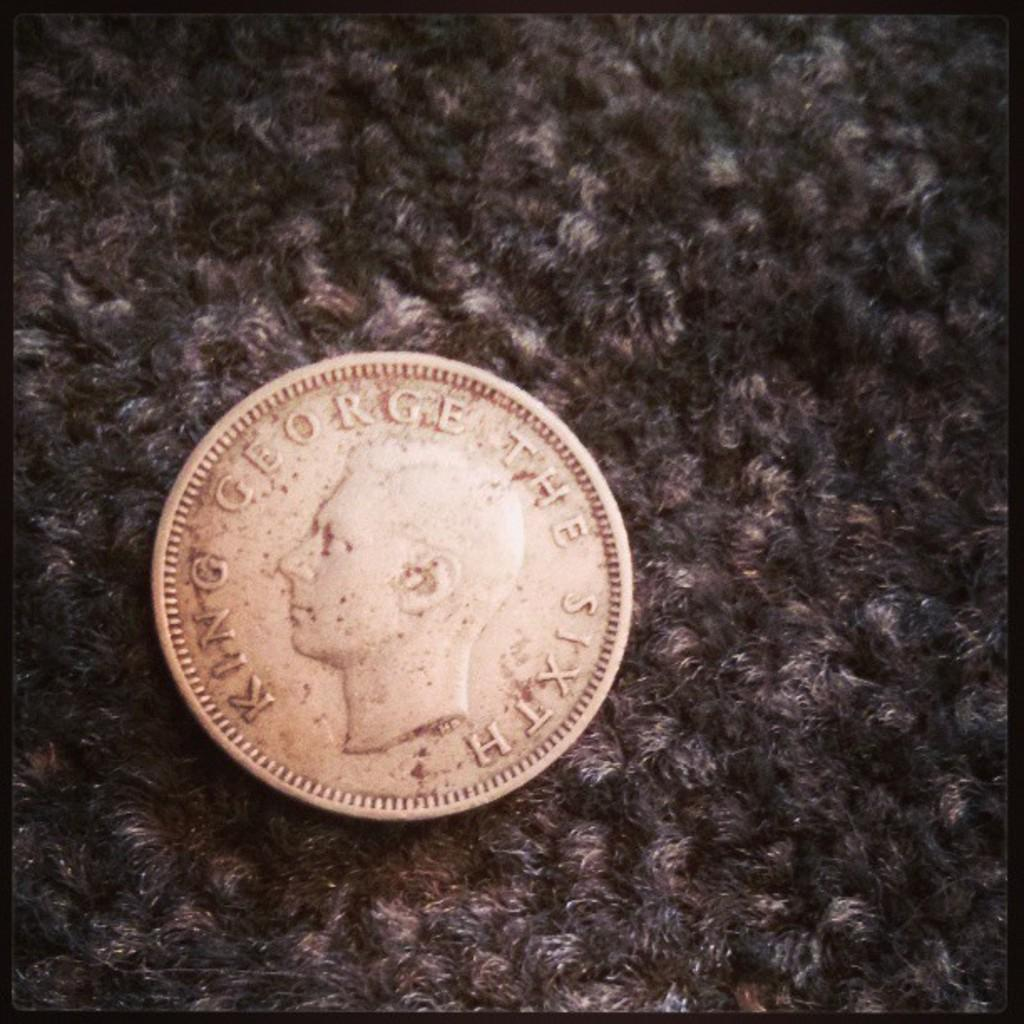<image>
Describe the image concisely. King George The Sixth is stamped into the face of this coin. 